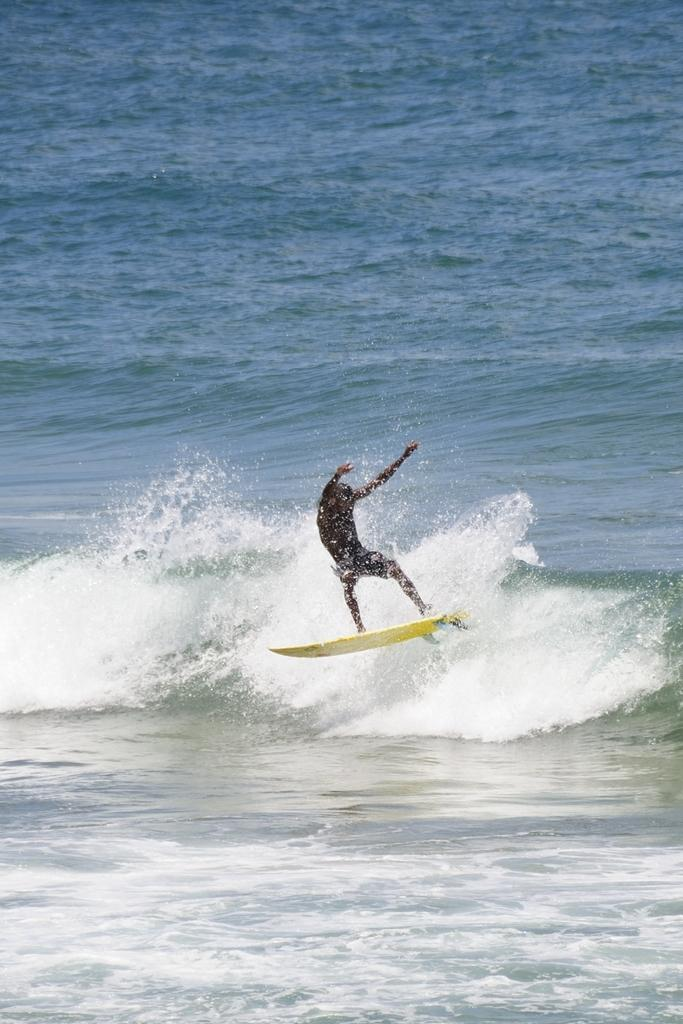What is present in the image that is not a solid object? There is water in the image. Who is present in the image? There is a man in the image. What is the man doing in the image? The man is standing on a surfboard and surfing on a wave. Are there any bursts of color visible in the image? There is no mention of bursts of color in the image; it primarily features water, a man, and a surfboard. Can you see any cobwebs in the image? There is no mention of cobwebs in the image; it primarily features water, a man, and a surfboard. 